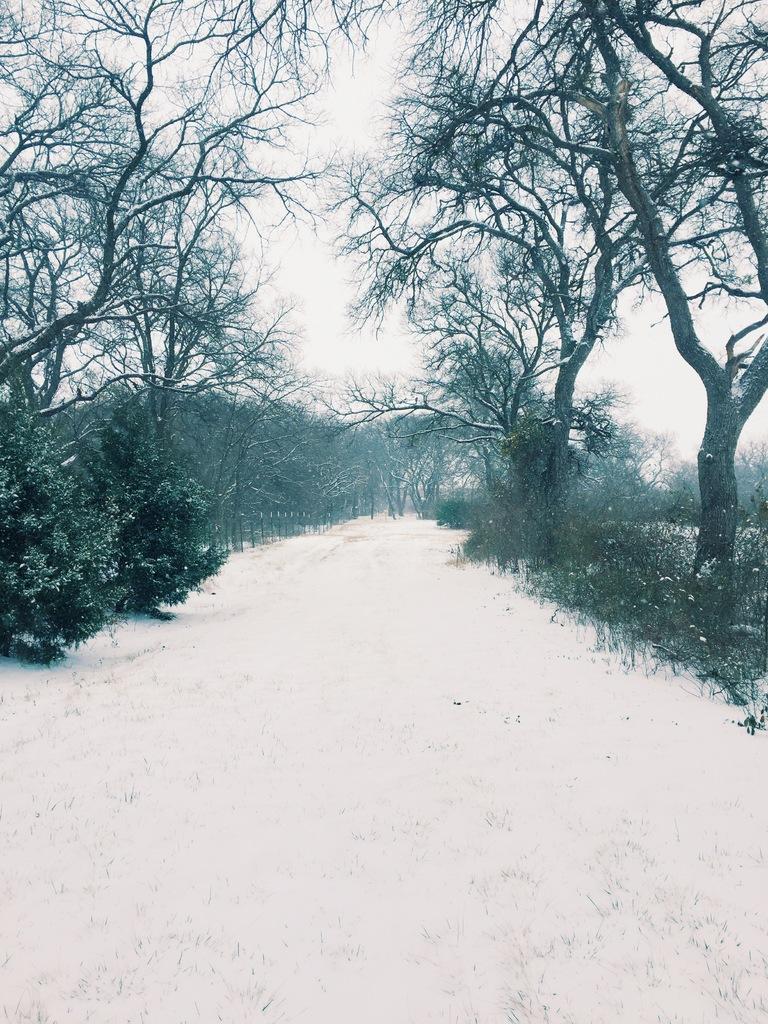Can you describe this image briefly? These are the trees with branches and leaves. I think this is the snow. These look like the plants. This is the sky. 